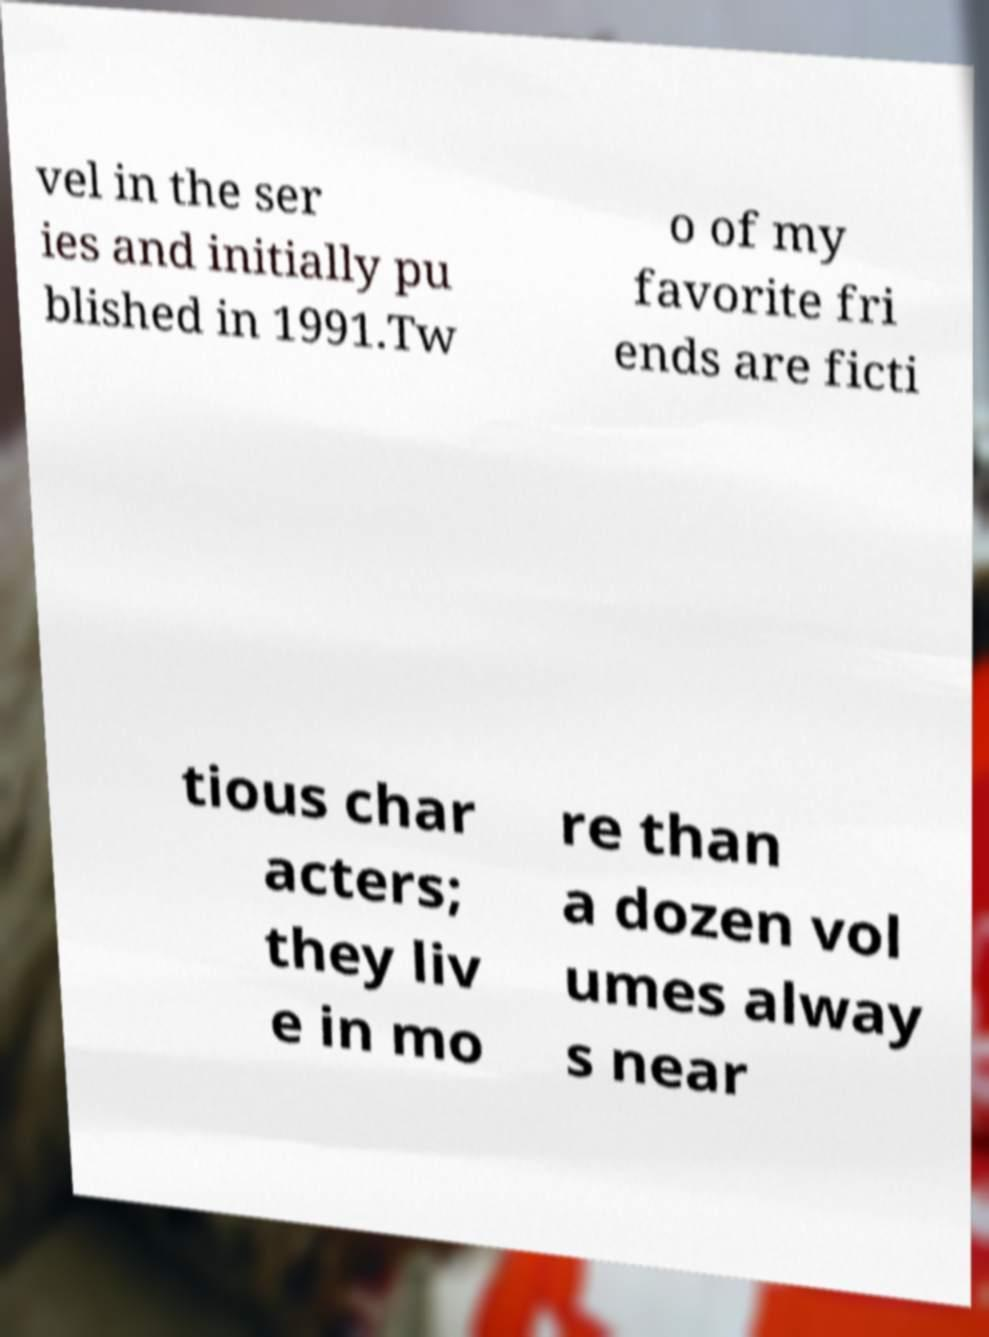What messages or text are displayed in this image? I need them in a readable, typed format. vel in the ser ies and initially pu blished in 1991.Tw o of my favorite fri ends are ficti tious char acters; they liv e in mo re than a dozen vol umes alway s near 